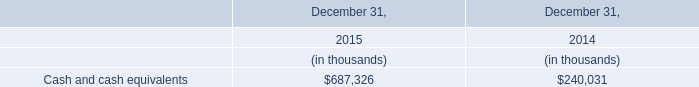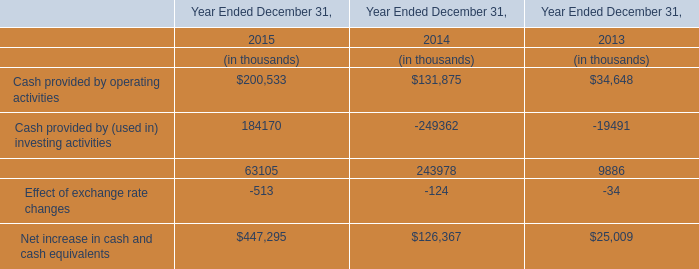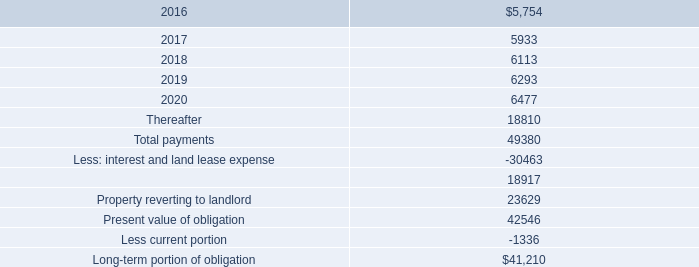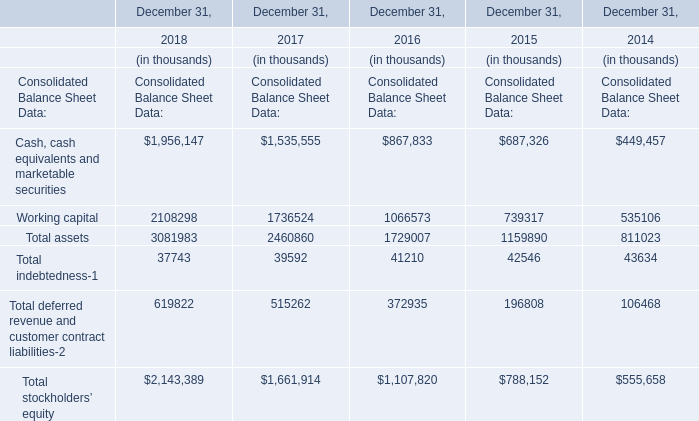What's the total amount of Consolidated Balance Sheet Data in 2018? 
Computations: (((((1956147 + 2108298) + 3081983) + 37743) + 619822) + 2143389)
Answer: 9947382.0. 